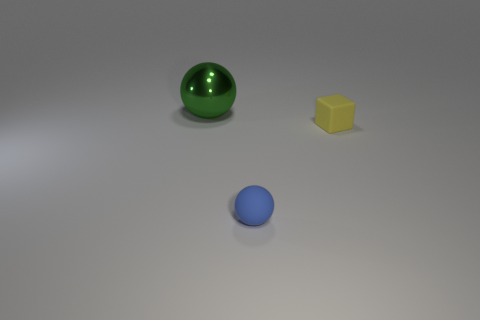Is there anything else that is the same size as the green object?
Your answer should be very brief. No. There is a big green thing that is the same shape as the tiny blue object; what material is it?
Provide a succinct answer. Metal. What number of gray objects are the same shape as the blue thing?
Your answer should be very brief. 0. Do the sphere left of the small blue thing and the cube have the same color?
Provide a short and direct response. No. There is a small object on the right side of the ball that is in front of the green thing left of the tiny yellow object; what shape is it?
Your response must be concise. Cube. There is a yellow cube; is it the same size as the sphere behind the tiny yellow cube?
Give a very brief answer. No. Are there any blocks that have the same size as the blue matte thing?
Provide a succinct answer. Yes. How many other things are the same material as the small cube?
Your answer should be very brief. 1. There is a object that is both to the right of the large green metal sphere and left of the yellow matte block; what color is it?
Keep it short and to the point. Blue. Is the material of the ball in front of the large green shiny sphere the same as the tiny object that is on the right side of the small blue object?
Give a very brief answer. Yes. 